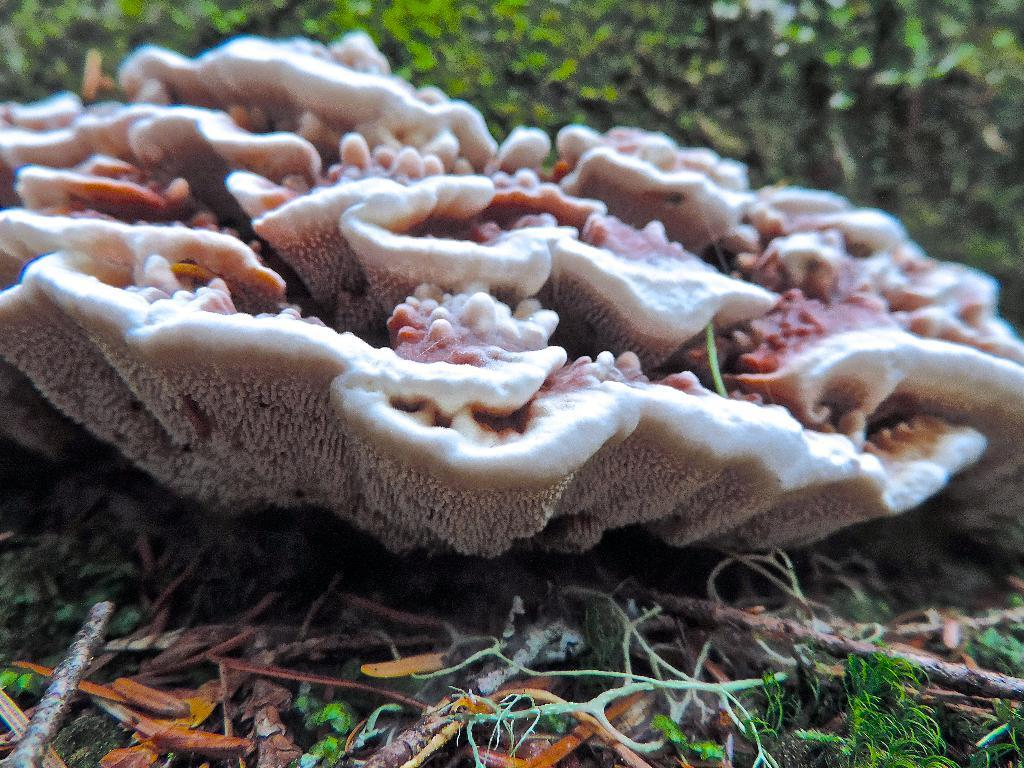What type of fungi can be seen in the image? There are mushrooms in the image. Where are the mushrooms located in the image? The mushrooms are on the ground. What decision does the hen make in the image? There is no hen present in the image, so it is not possible to determine any decisions made by a hen. 